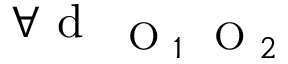<formula> <loc_0><loc_0><loc_500><loc_500>\forall d _ { O _ { 1 } O _ { 2 } }</formula> 